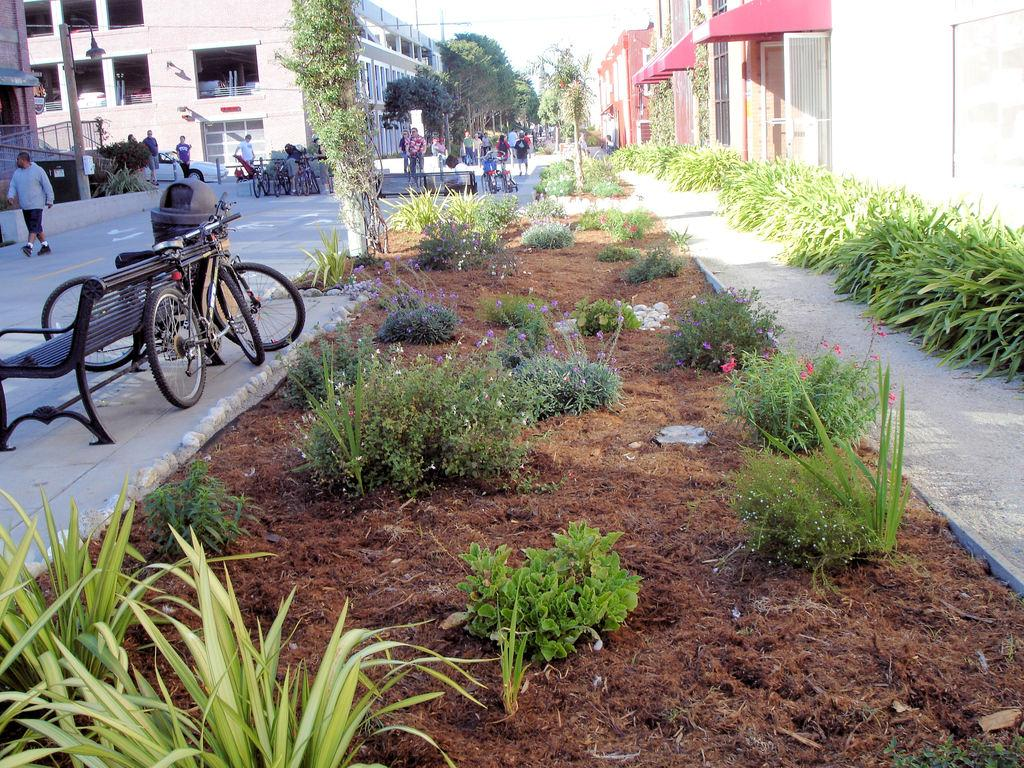What is the person in the image doing? The person in the image is walking. What can be found in the image for someone to sit on? There is a bench in the image. What mode of transportation is visible in the image? There is a bicycle in the image. What type of vegetation is present in the image? There are plants and trees in the image. What type of ground surface is visible in the image? There is soil in the image. Are there any other people visible in the image? Yes, there are a few persons standing in the distance. What type of structure can be seen in the image? There is a building in the image. What type of punishment is being administered to the person's son in the image? There is no son or punishment present in the image. What type of flesh can be seen on the person in the image? The image does not show any flesh or body parts of the person; it only shows the person walking. 